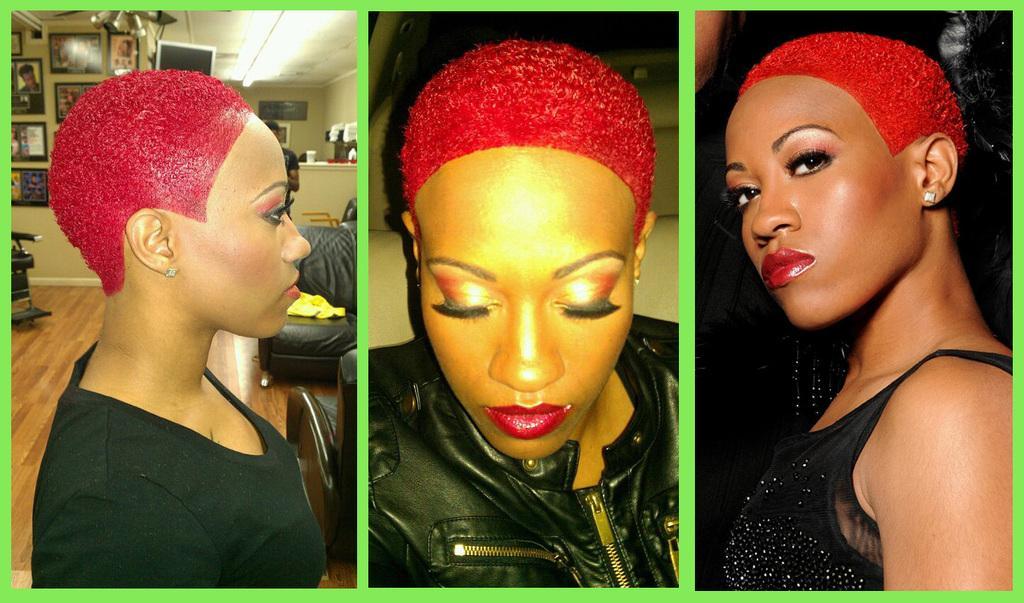How would you summarize this image in a sentence or two? This is a collage image. In this image I can see the person with the black color dress. In the background I can see the couches, chair and the frames to the wall. I can see the screen and the lights at the top. 